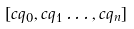<formula> <loc_0><loc_0><loc_500><loc_500>[ c q _ { 0 } , c q _ { 1 } \dots , c q _ { n } ]</formula> 